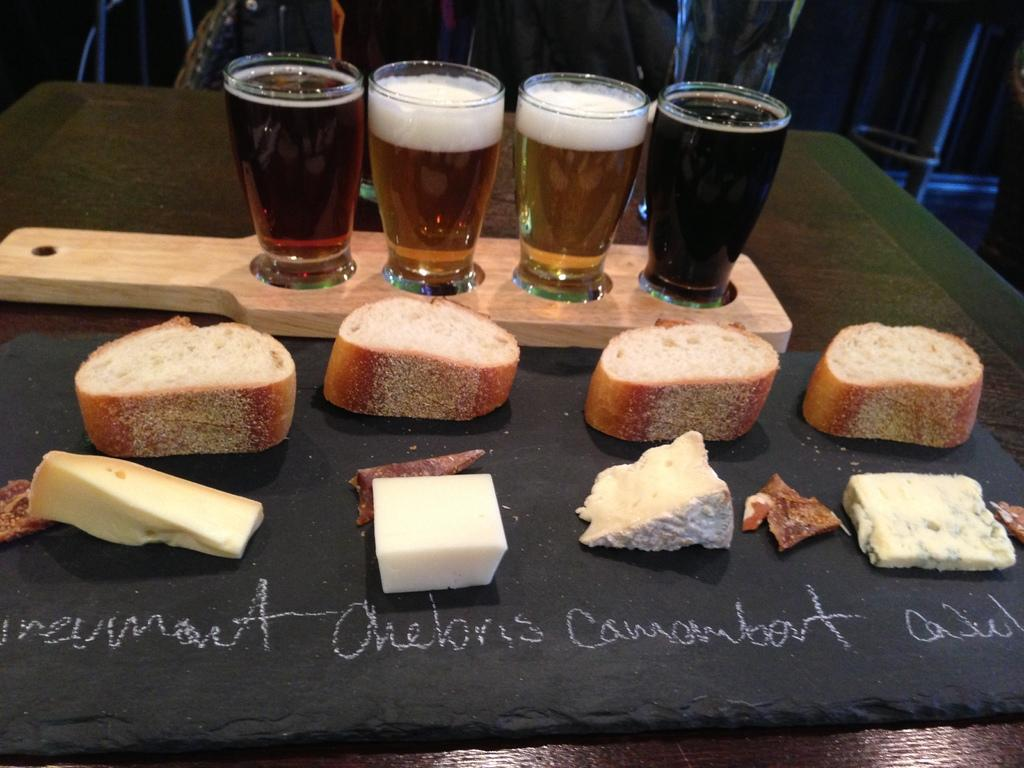What objects are on a wooden surface in the image? There are glasses on a wooden object in the image. What can be seen on a black surface in the image? There are food items on a black surface in the image. How would you describe the overall lighting in the image? The background of the image is dark. What type of apparel is the cat wearing in the image? There is no cat present in the image, so it cannot be determined if any apparel is being worn. 